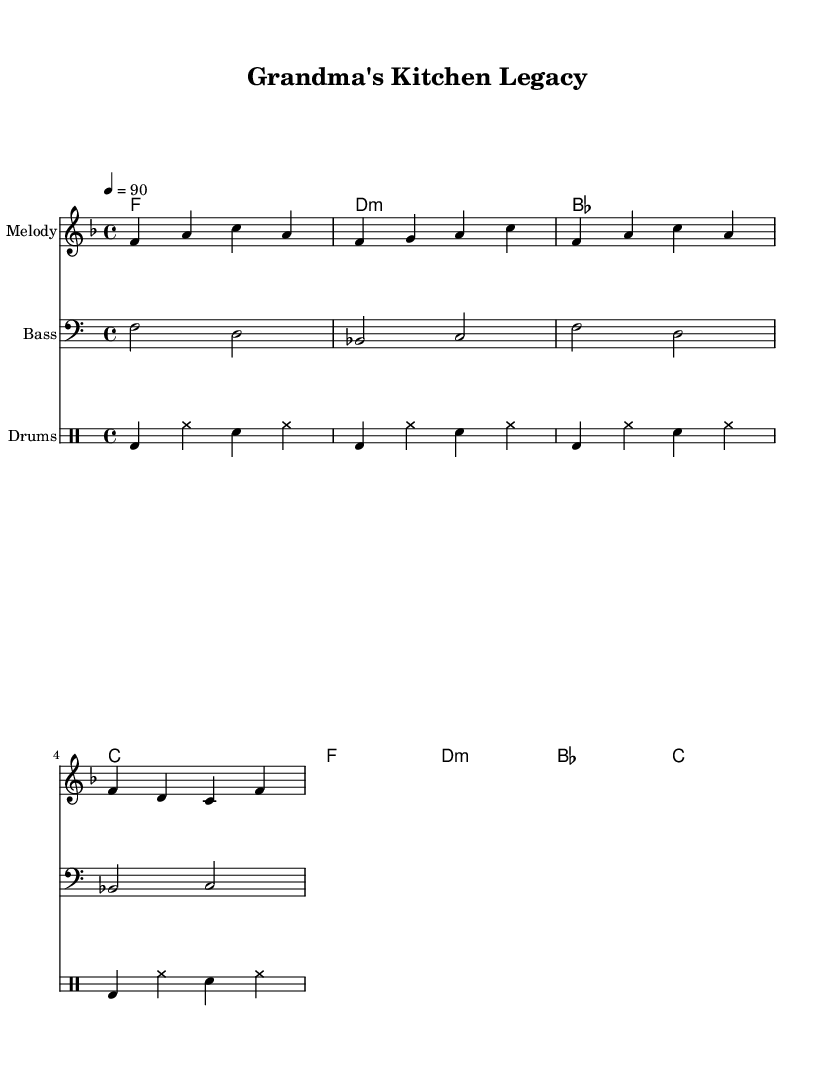What is the key signature of this music? The key signature is F major, which has one flat (B flat). The presence of B flat can be confirmed by looking at the key signature at the beginning of the sheet music.
Answer: F major What is the time signature of the piece? The time signature is 4/4, which means there are four beats per measure and a quarter note receives one beat. This can be seen at the beginning of the music sheet, noted after the key signature.
Answer: 4/4 What is the tempo marking? The tempo marking is quarter note = 90, indicating a moderate speed for the performance. This can be found near the beginning of the score, indicating how fast the piece should be played.
Answer: 90 How many measures are in the melody section? There are four measures in the melody section, which can be counted by observing the music staff and identifying the distinct bars separated by vertical lines.
Answer: 4 What type of text is used in this piece? The text is lyrics, as indicated by the separate lyrics staff below the melody, containing words that align with the musical notes. The nature of the lyrics suggests a focus on family traditions and nostalgia.
Answer: Lyrics What instruments are listed in the sheet music? The instruments listed are "Melody," "Bass," and "Drums." Each instrument is indicated in the corresponding sections of the score, showing the instrumentation for the piece.
Answer: Melody, Bass, Drums How does the structure of this rap reflect its theme of culinary traditions? The structure includes a straightforward melody that complements the rhythmic and spoken qualities typical of rap, emphasizing storytelling about cherished family recipes and traditions through the lyrics. This interplay reinforces the nostalgic theme.
Answer: Straightforward melody and rhythmic structure 